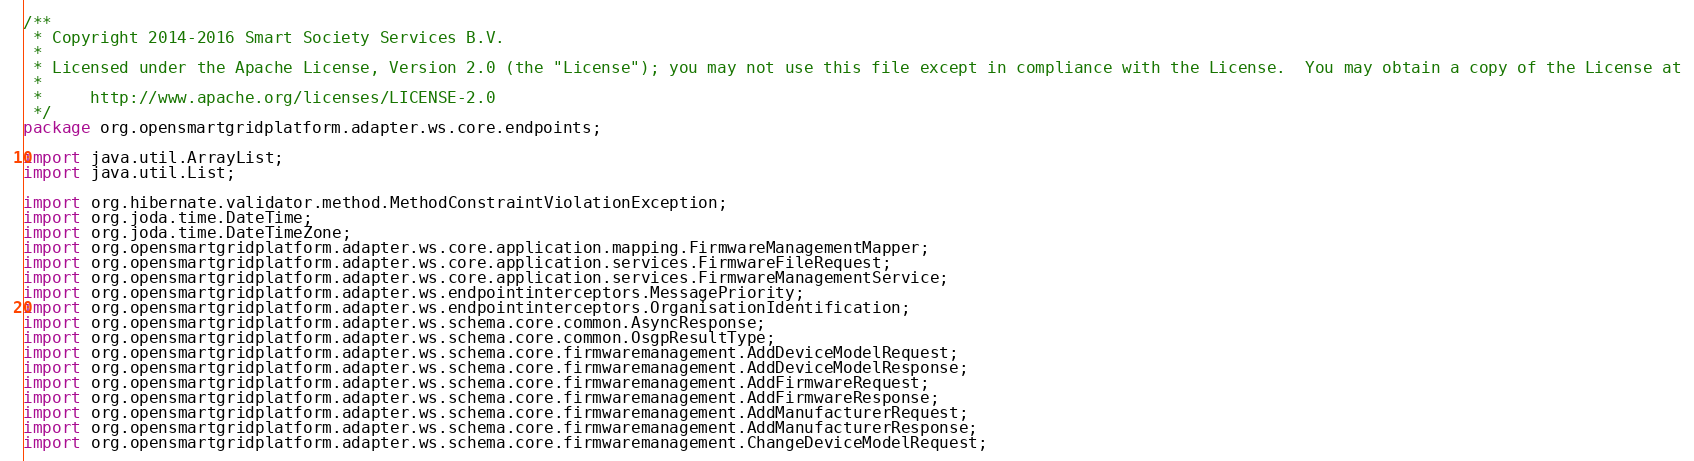Convert code to text. <code><loc_0><loc_0><loc_500><loc_500><_Java_>/**
 * Copyright 2014-2016 Smart Society Services B.V.
 *
 * Licensed under the Apache License, Version 2.0 (the "License"); you may not use this file except in compliance with the License.  You may obtain a copy of the License at
 *
 *     http://www.apache.org/licenses/LICENSE-2.0
 */
package org.opensmartgridplatform.adapter.ws.core.endpoints;

import java.util.ArrayList;
import java.util.List;

import org.hibernate.validator.method.MethodConstraintViolationException;
import org.joda.time.DateTime;
import org.joda.time.DateTimeZone;
import org.opensmartgridplatform.adapter.ws.core.application.mapping.FirmwareManagementMapper;
import org.opensmartgridplatform.adapter.ws.core.application.services.FirmwareFileRequest;
import org.opensmartgridplatform.adapter.ws.core.application.services.FirmwareManagementService;
import org.opensmartgridplatform.adapter.ws.endpointinterceptors.MessagePriority;
import org.opensmartgridplatform.adapter.ws.endpointinterceptors.OrganisationIdentification;
import org.opensmartgridplatform.adapter.ws.schema.core.common.AsyncResponse;
import org.opensmartgridplatform.adapter.ws.schema.core.common.OsgpResultType;
import org.opensmartgridplatform.adapter.ws.schema.core.firmwaremanagement.AddDeviceModelRequest;
import org.opensmartgridplatform.adapter.ws.schema.core.firmwaremanagement.AddDeviceModelResponse;
import org.opensmartgridplatform.adapter.ws.schema.core.firmwaremanagement.AddFirmwareRequest;
import org.opensmartgridplatform.adapter.ws.schema.core.firmwaremanagement.AddFirmwareResponse;
import org.opensmartgridplatform.adapter.ws.schema.core.firmwaremanagement.AddManufacturerRequest;
import org.opensmartgridplatform.adapter.ws.schema.core.firmwaremanagement.AddManufacturerResponse;
import org.opensmartgridplatform.adapter.ws.schema.core.firmwaremanagement.ChangeDeviceModelRequest;</code> 